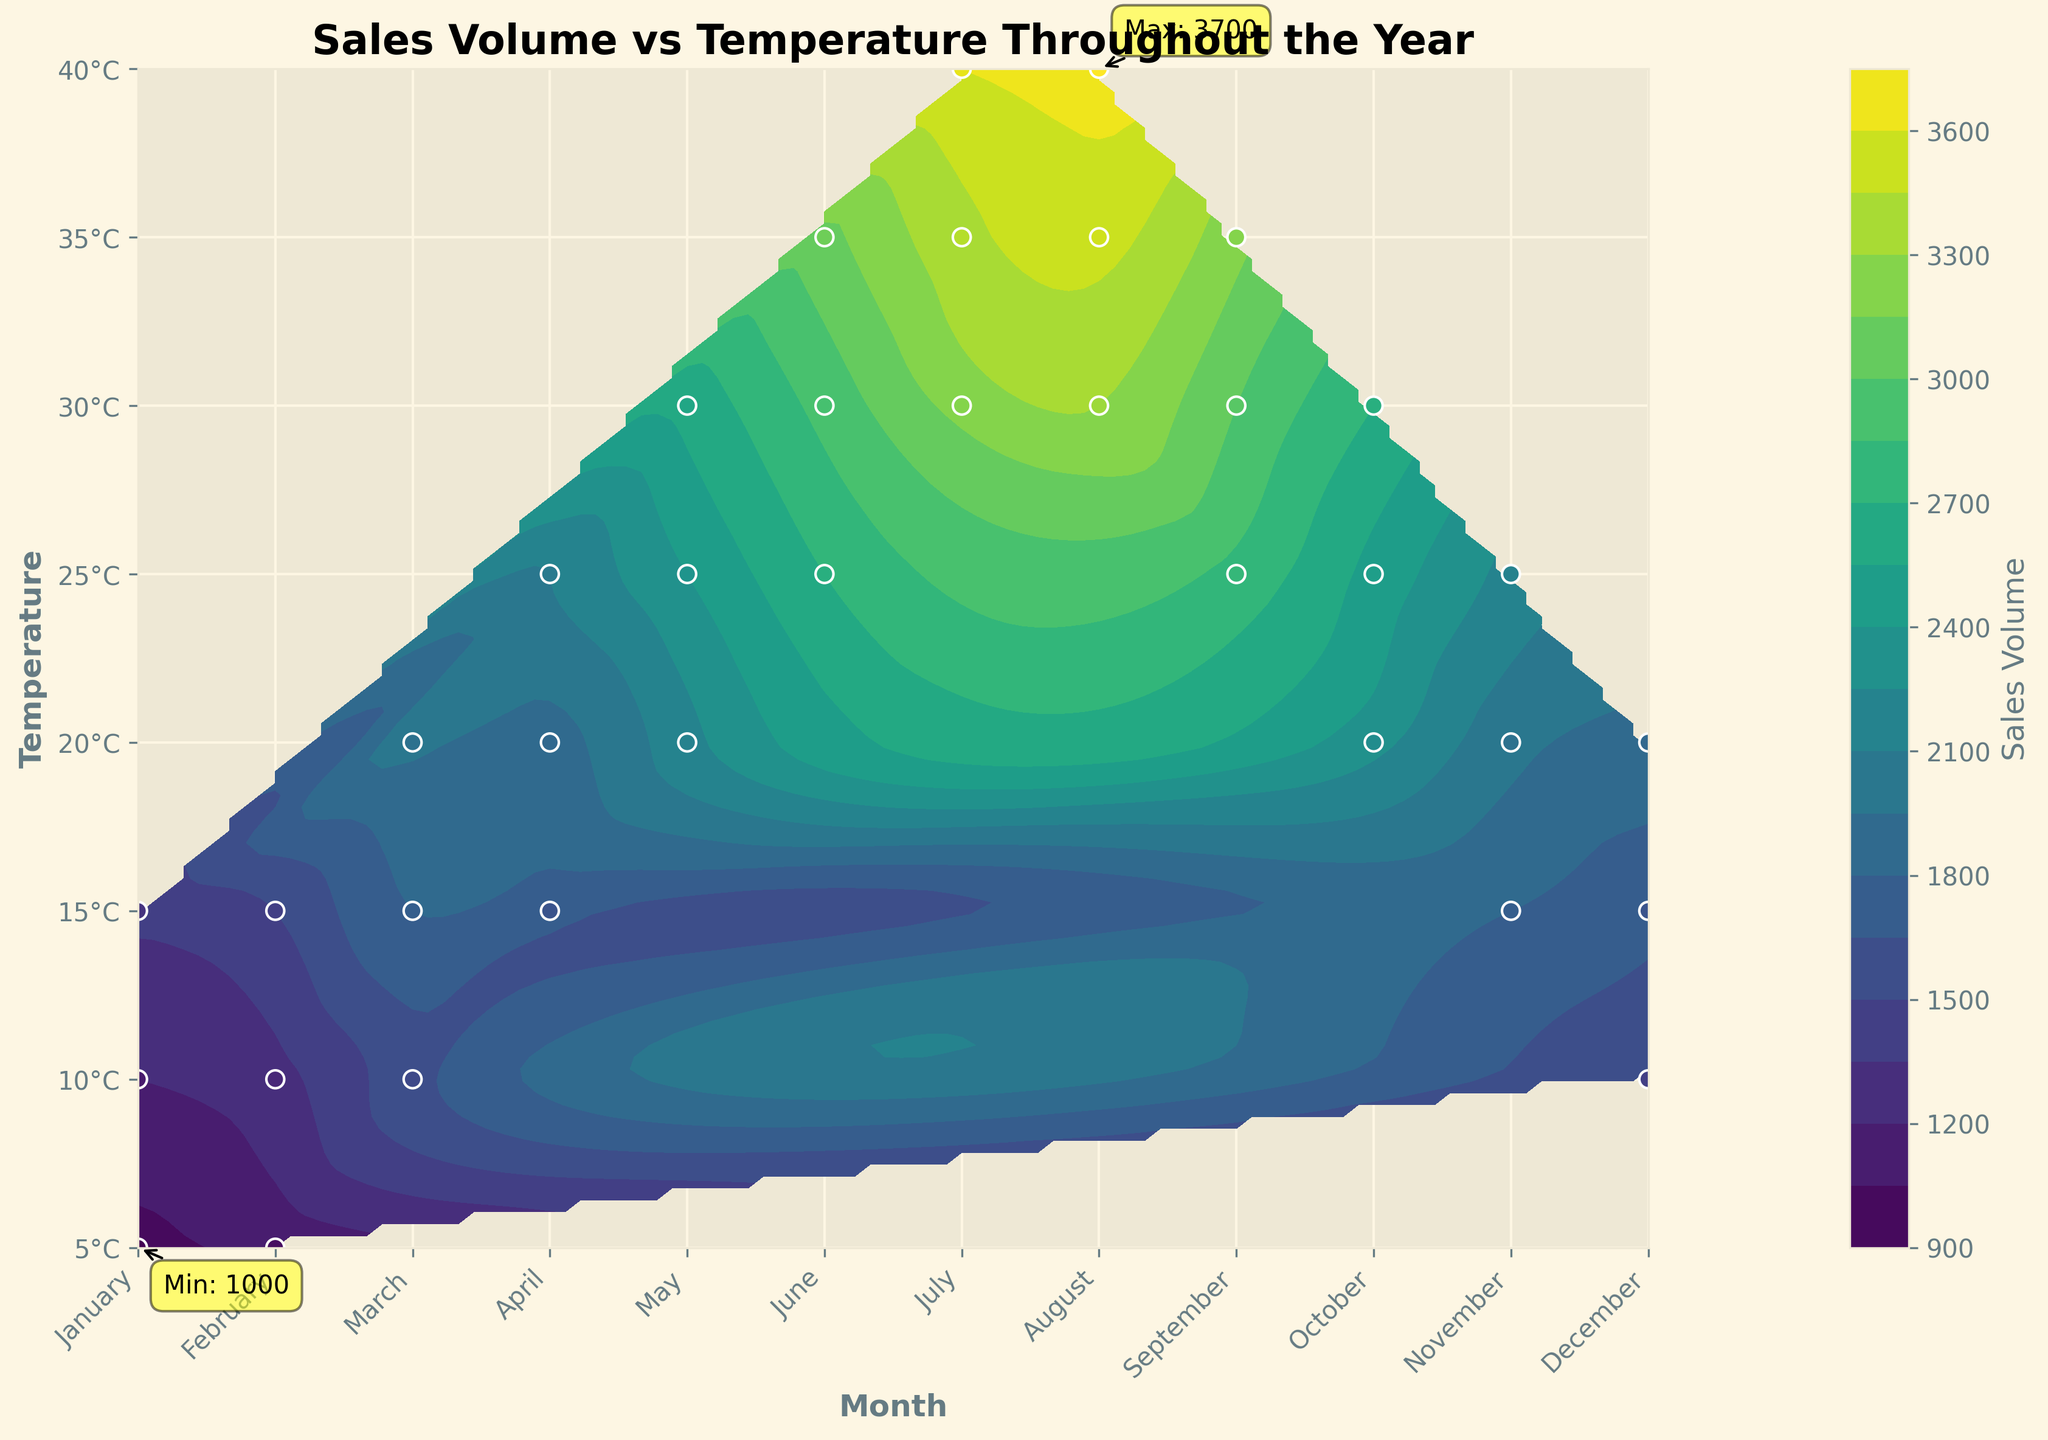What is the title of the figure? The title can be found at the top of the figure and typically provides a summary of what the figure is about. Here, the title is "Sales Volume vs Temperature Throughout the Year".
Answer: Sales Volume vs Temperature Throughout the Year What does the color bar represent? The color bar is a key that indicates what the colors in the contour plot represent. It is usually labeled and helps in understanding the scale of the visualized data. Here, it shows that the colors represent the "Sales Volume".
Answer: Sales Volume In which month and at what temperature was the maximum sales volume recorded? The figure is annotated where the maximum sales volume occurs. It highlights both the month and the temperature at that point. Based on the annotation, this point corresponds to July at 40°C.
Answer: July, 40°C How does the sales volume trend with temperature variation in the summer months (June, July, August)? Summer months are often characterized by high temperatures. Examining the contour plot, the sales volume increases with rising temperatures during these months, especially visible near the highest sales volumes.
Answer: Increasing Which month and temperature had the minimum sales volume? The figure is annotated indicating the minimum sales volume. This annotation shows that the minimum occurs in January at 5°C.
Answer: January, 5°C Which months have a noticeable increase in sales volume as the temperature increases from 10°C to 25°C? Looking at the gradient of the contour lines from 10°C to 25°C across different months, both March and May exhibit a noticeable increase in sales volume as temperature rises. This is indicated by the dense contour lines moving upwards in sales volume.
Answer: March, May What can be inferred about sales volume in the winter months when compared to the summer months? By comparing the contours from winter months (December, January, February) to summer months (June, July, August), it is evident that the sales volume is generally lower in winter and higher in summer. This can be inferred from the color intensity and contour density differences.
Answer: Lower in winter, higher in summer How are the sales volumes spread throughout the year for temperatures around 20°C? Contour lines around 20°C should be examined across different months. Notably, in months like October, sales volume increases moderately, but in peak summer months, the increase is sharper, reflecting higher sales volumes. The spread shows a gradual to steep rise depending on the season.
Answer: Moderate to steep rise depending on the month Is there any month where sales volume peaks at intermediate temperatures (20-30°C)? Checking the color intensities and contours within the 20-30°C range, May stands out where sales volume peaks significantly, indicated by the highest color intensity within this temperature range.
Answer: May Describe the general trend in sales volume as temperature increases. By observing the overall contour lines, there is a general upward trend in sales volume with increases in temperature. This can be seen by the color shift towards intense colors at higher temperatures, indicating greater sales volumes.
Answer: Increases 